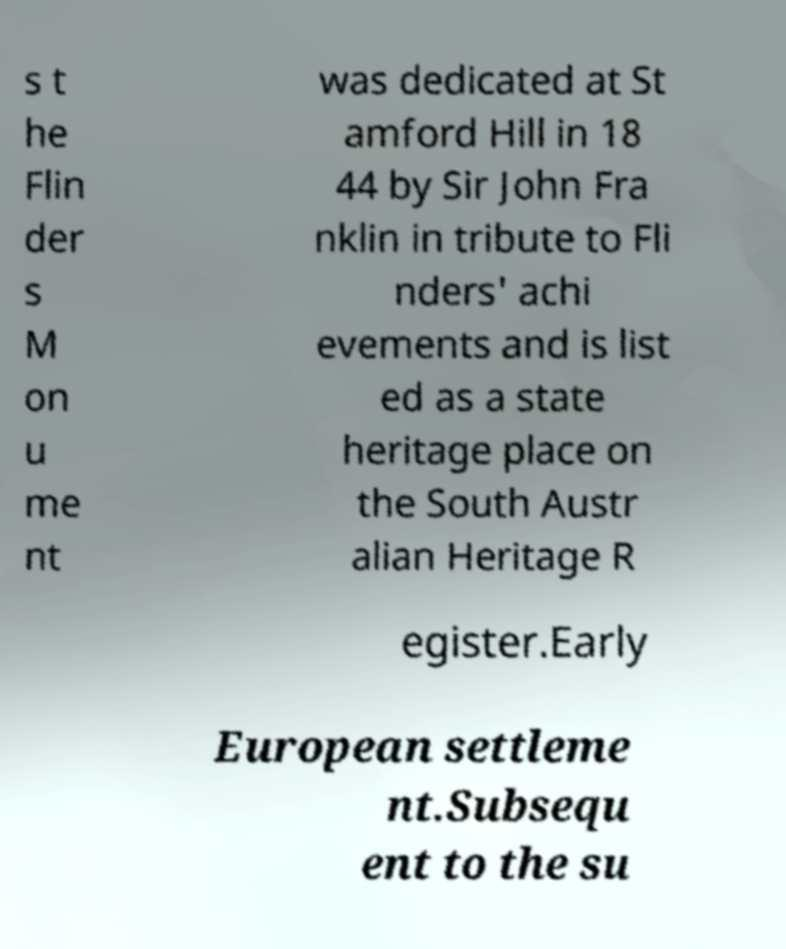Please read and relay the text visible in this image. What does it say? s t he Flin der s M on u me nt was dedicated at St amford Hill in 18 44 by Sir John Fra nklin in tribute to Fli nders' achi evements and is list ed as a state heritage place on the South Austr alian Heritage R egister.Early European settleme nt.Subsequ ent to the su 